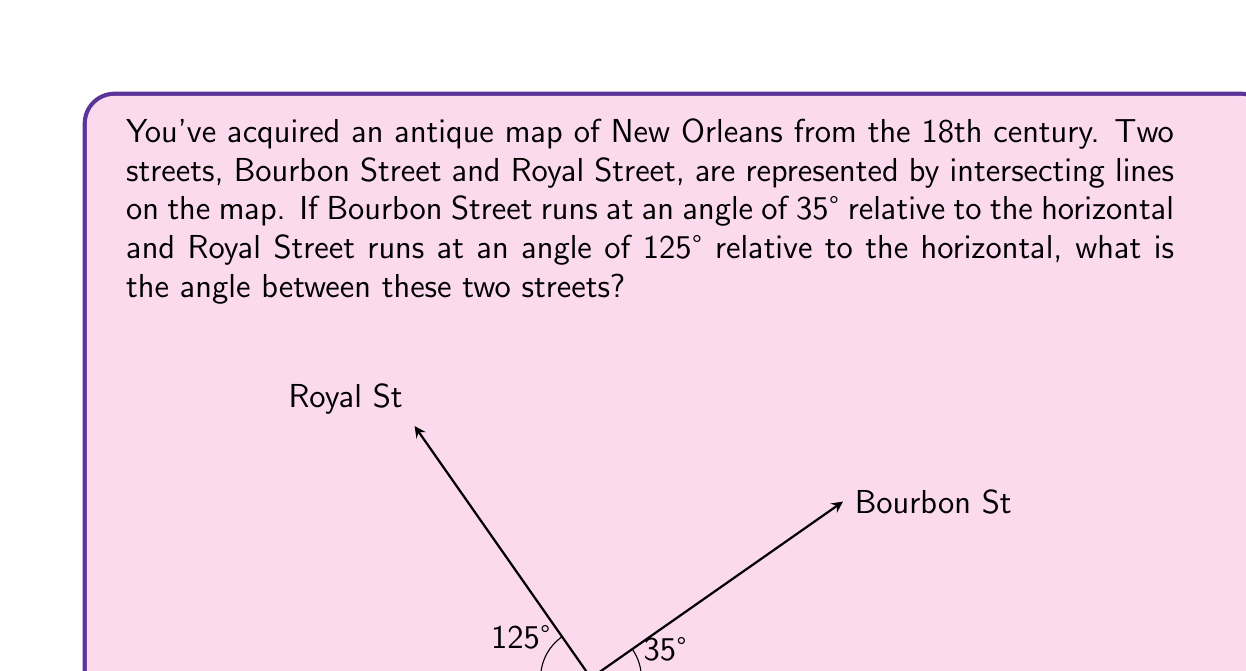Solve this math problem. Let's approach this step-by-step:

1) First, we need to understand what the given angles mean. Both angles are measured relative to the horizontal, which serves as our reference line.

2) To find the angle between the two streets, we need to subtract the smaller angle from the larger angle:

   $$125° - 35° = 90°$$

3) However, this is not always the correct approach. We need to consider whether this result gives us the smaller angle between the lines.

4) In geometry, intersecting lines form two pairs of vertical angles. The sum of the four angles around the intersection point is always 360°.

5) The other angle formed by these streets would be:

   $$360° - 90° = 270°$$

6) Since we're looking for the smaller angle, our answer is 90°.

7) We can verify this using the concept of supplementary angles. The sum of the smaller and larger angles between intersecting lines is always 180°:

   $$90° + 90° = 180°$$

Therefore, the angle between Bourbon Street and Royal Street on your antique map is 90°.
Answer: 90° 